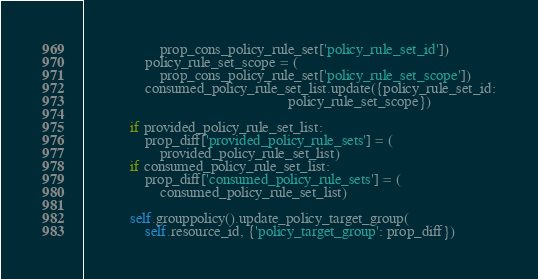Convert code to text. <code><loc_0><loc_0><loc_500><loc_500><_Python_>                    prop_cons_policy_rule_set['policy_rule_set_id'])
                policy_rule_set_scope = (
                    prop_cons_policy_rule_set['policy_rule_set_scope'])
                consumed_policy_rule_set_list.update({policy_rule_set_id:
                                                      policy_rule_set_scope})

            if provided_policy_rule_set_list:
                prop_diff['provided_policy_rule_sets'] = (
                    provided_policy_rule_set_list)
            if consumed_policy_rule_set_list:
                prop_diff['consumed_policy_rule_sets'] = (
                    consumed_policy_rule_set_list)

            self.grouppolicy().update_policy_target_group(
                self.resource_id, {'policy_target_group': prop_diff})

</code> 